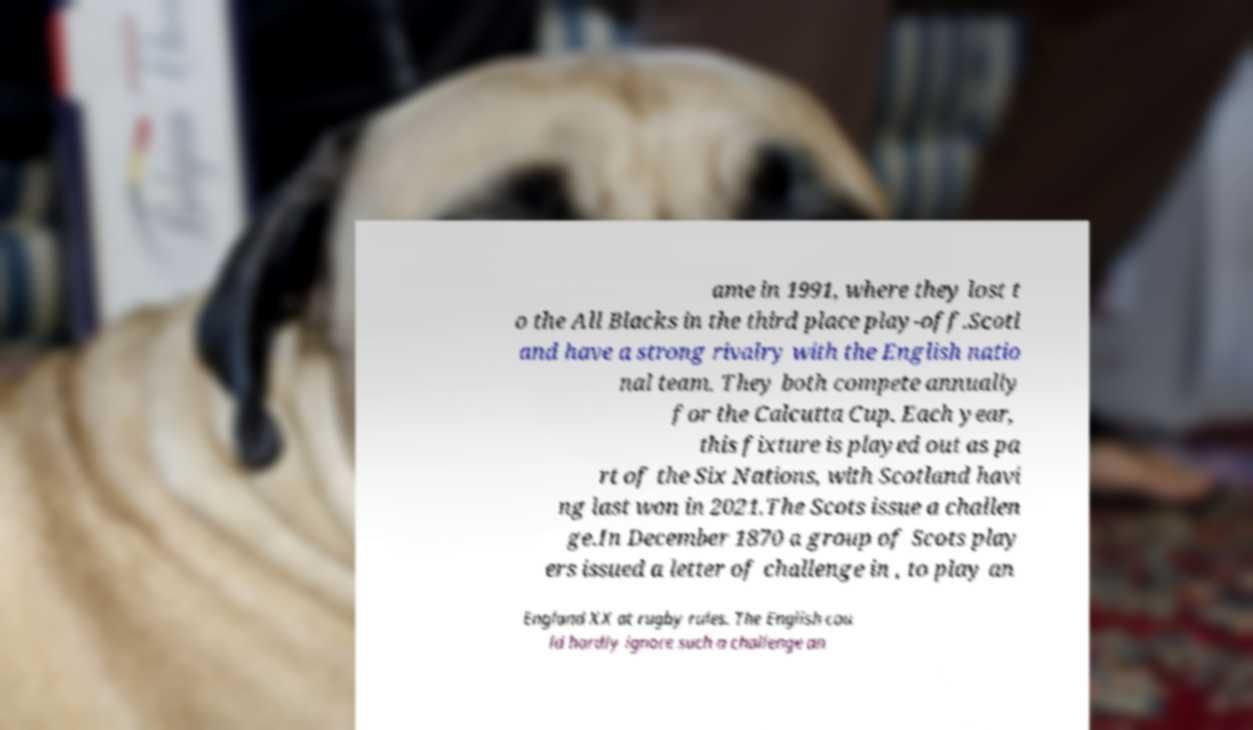There's text embedded in this image that I need extracted. Can you transcribe it verbatim? ame in 1991, where they lost t o the All Blacks in the third place play-off.Scotl and have a strong rivalry with the English natio nal team. They both compete annually for the Calcutta Cup. Each year, this fixture is played out as pa rt of the Six Nations, with Scotland havi ng last won in 2021.The Scots issue a challen ge.In December 1870 a group of Scots play ers issued a letter of challenge in , to play an England XX at rugby rules. The English cou ld hardly ignore such a challenge an 